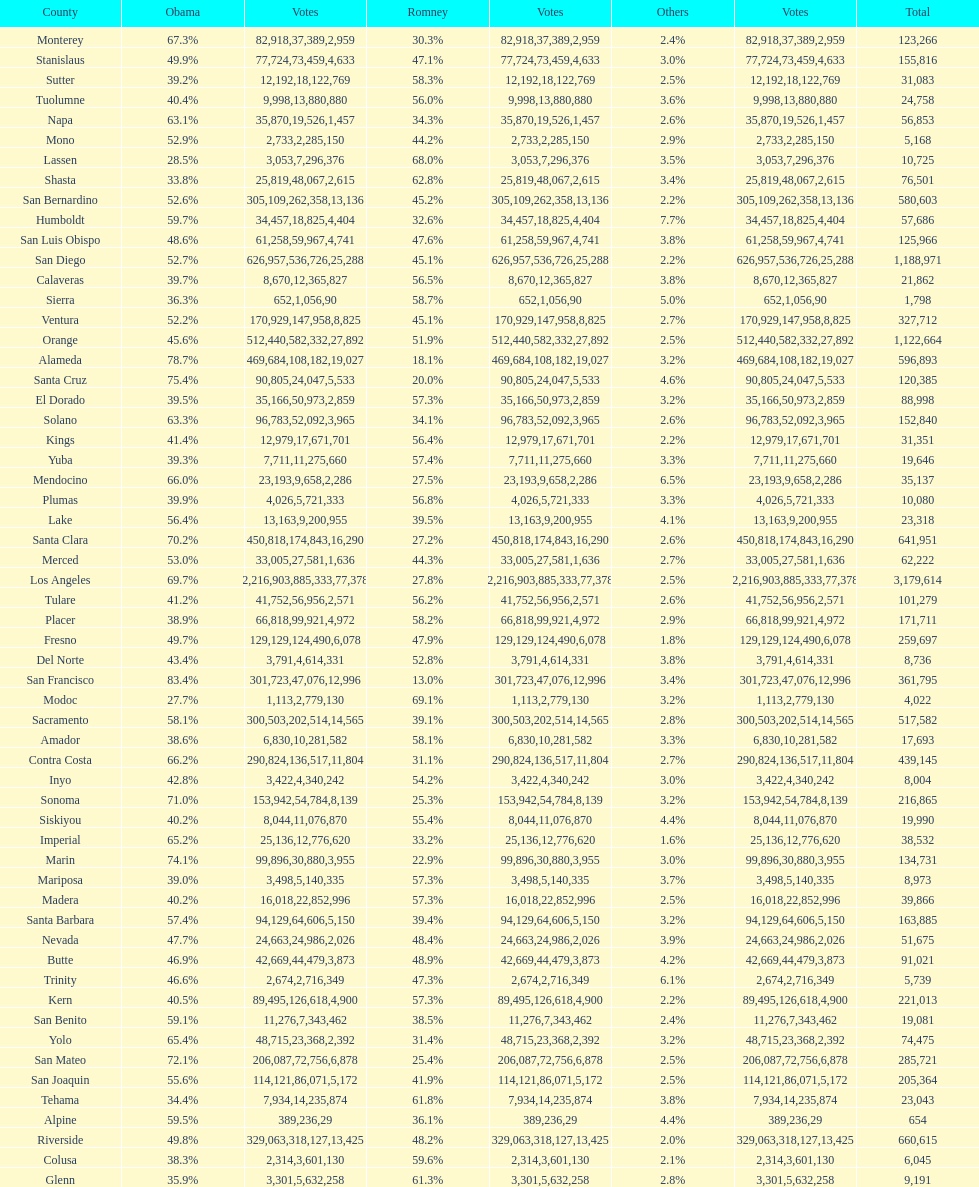What is the total number of votes for amador? 17693. 